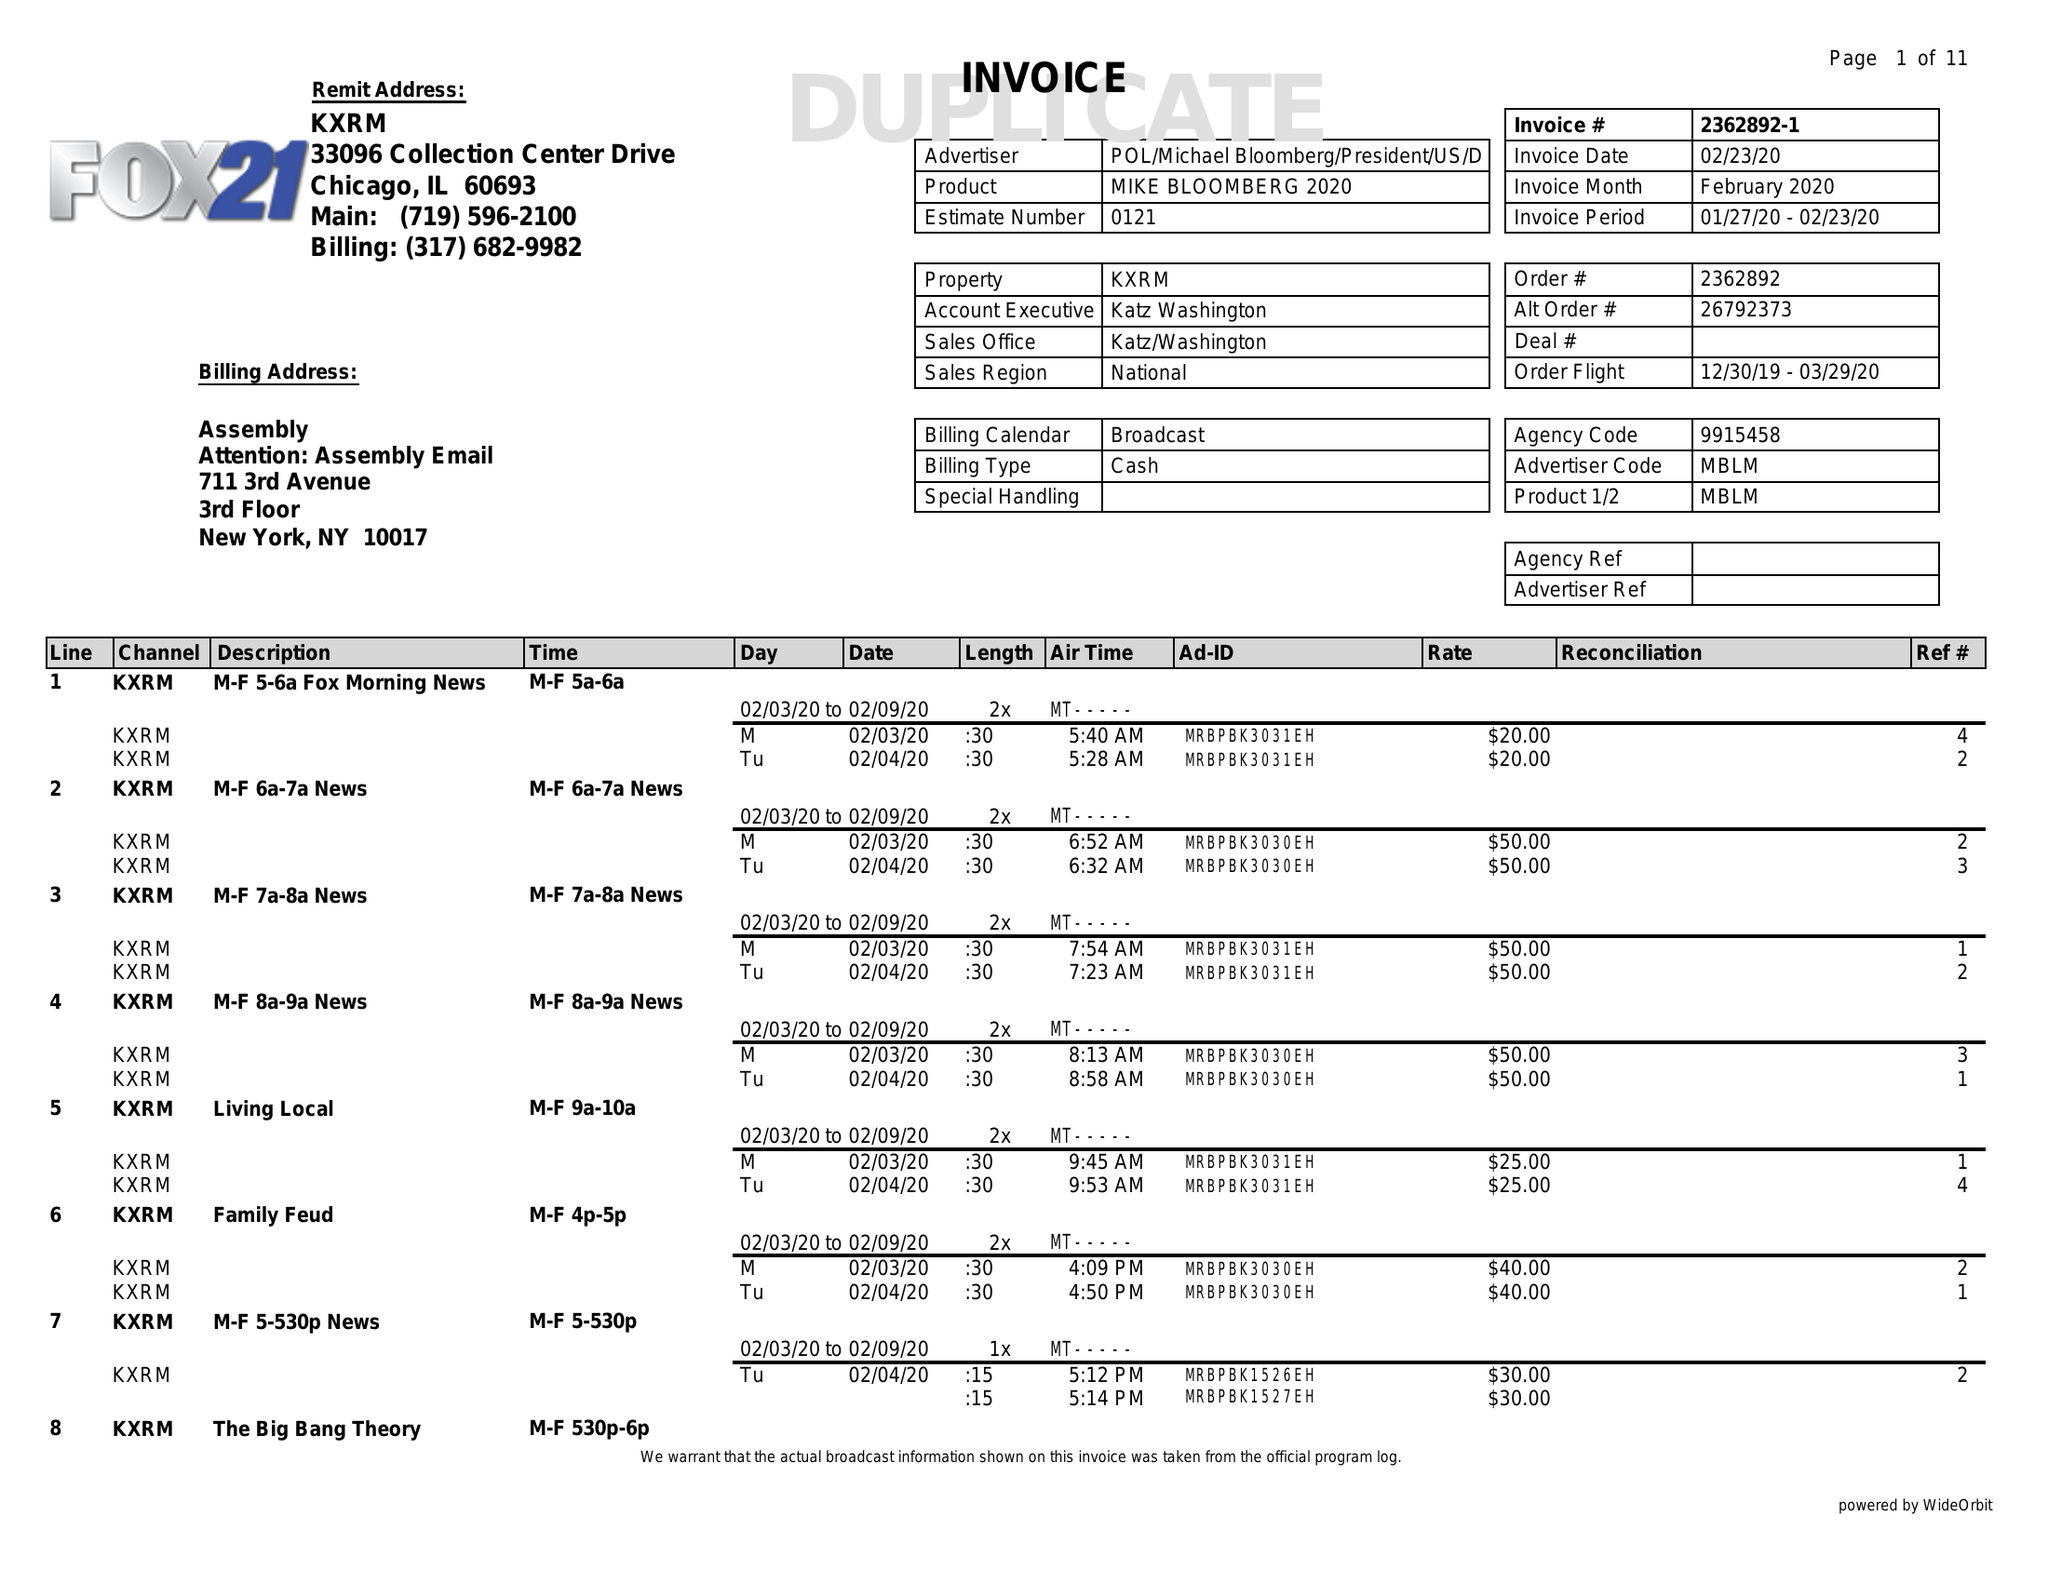What is the value for the flight_to?
Answer the question using a single word or phrase. 03/29/20 